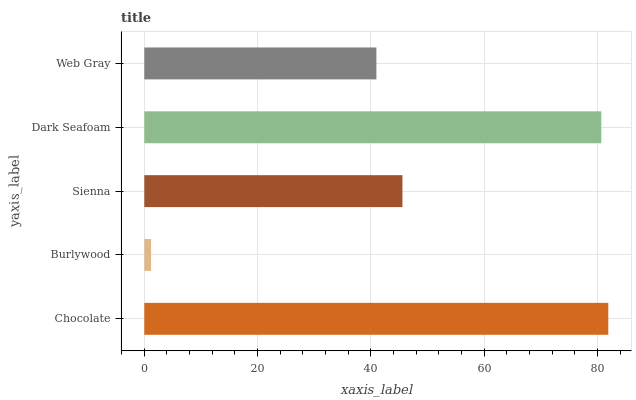Is Burlywood the minimum?
Answer yes or no. Yes. Is Chocolate the maximum?
Answer yes or no. Yes. Is Sienna the minimum?
Answer yes or no. No. Is Sienna the maximum?
Answer yes or no. No. Is Sienna greater than Burlywood?
Answer yes or no. Yes. Is Burlywood less than Sienna?
Answer yes or no. Yes. Is Burlywood greater than Sienna?
Answer yes or no. No. Is Sienna less than Burlywood?
Answer yes or no. No. Is Sienna the high median?
Answer yes or no. Yes. Is Sienna the low median?
Answer yes or no. Yes. Is Web Gray the high median?
Answer yes or no. No. Is Dark Seafoam the low median?
Answer yes or no. No. 